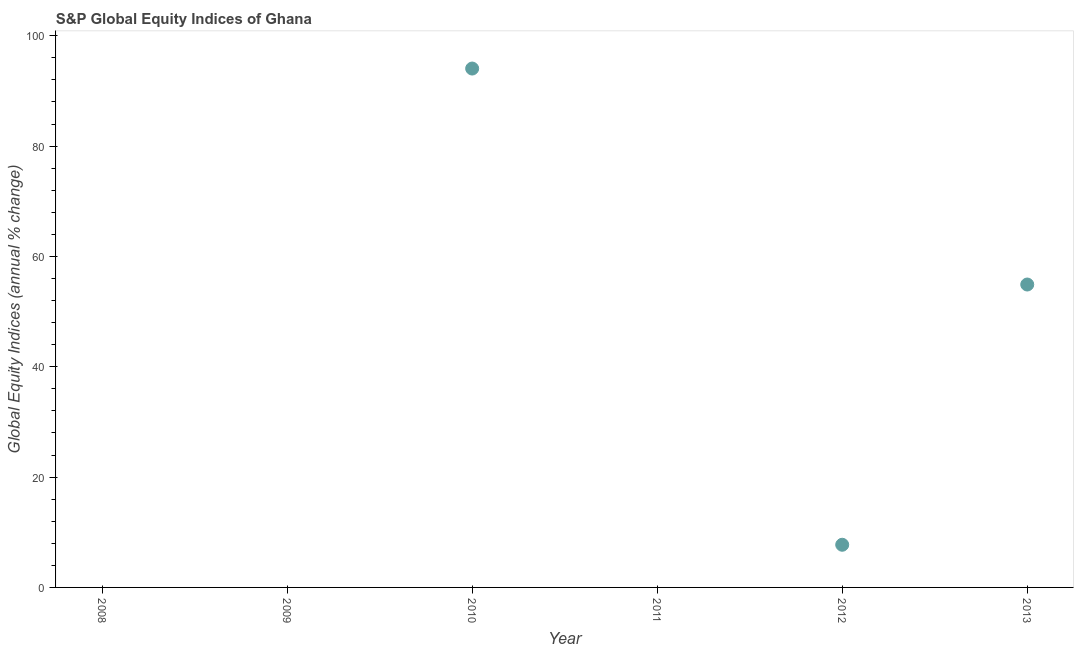What is the s&p global equity indices in 2008?
Your answer should be very brief. 0. Across all years, what is the maximum s&p global equity indices?
Offer a very short reply. 94.06. What is the sum of the s&p global equity indices?
Ensure brevity in your answer.  156.71. What is the difference between the s&p global equity indices in 2012 and 2013?
Give a very brief answer. -47.18. What is the average s&p global equity indices per year?
Offer a very short reply. 26.12. What is the median s&p global equity indices?
Keep it short and to the point. 3.87. In how many years, is the s&p global equity indices greater than 12 %?
Keep it short and to the point. 2. What is the ratio of the s&p global equity indices in 2010 to that in 2012?
Provide a short and direct response. 12.16. Is the s&p global equity indices in 2010 less than that in 2013?
Your answer should be very brief. No. What is the difference between the highest and the second highest s&p global equity indices?
Your answer should be very brief. 39.15. What is the difference between the highest and the lowest s&p global equity indices?
Your response must be concise. 94.06. In how many years, is the s&p global equity indices greater than the average s&p global equity indices taken over all years?
Keep it short and to the point. 2. How many dotlines are there?
Your answer should be very brief. 1. Are the values on the major ticks of Y-axis written in scientific E-notation?
Give a very brief answer. No. Does the graph contain any zero values?
Give a very brief answer. Yes. Does the graph contain grids?
Provide a short and direct response. No. What is the title of the graph?
Your answer should be compact. S&P Global Equity Indices of Ghana. What is the label or title of the Y-axis?
Your response must be concise. Global Equity Indices (annual % change). What is the Global Equity Indices (annual % change) in 2009?
Your answer should be very brief. 0. What is the Global Equity Indices (annual % change) in 2010?
Your answer should be compact. 94.06. What is the Global Equity Indices (annual % change) in 2012?
Make the answer very short. 7.74. What is the Global Equity Indices (annual % change) in 2013?
Offer a terse response. 54.91. What is the difference between the Global Equity Indices (annual % change) in 2010 and 2012?
Your answer should be very brief. 86.33. What is the difference between the Global Equity Indices (annual % change) in 2010 and 2013?
Your answer should be very brief. 39.15. What is the difference between the Global Equity Indices (annual % change) in 2012 and 2013?
Provide a short and direct response. -47.18. What is the ratio of the Global Equity Indices (annual % change) in 2010 to that in 2012?
Make the answer very short. 12.16. What is the ratio of the Global Equity Indices (annual % change) in 2010 to that in 2013?
Offer a terse response. 1.71. What is the ratio of the Global Equity Indices (annual % change) in 2012 to that in 2013?
Provide a succinct answer. 0.14. 